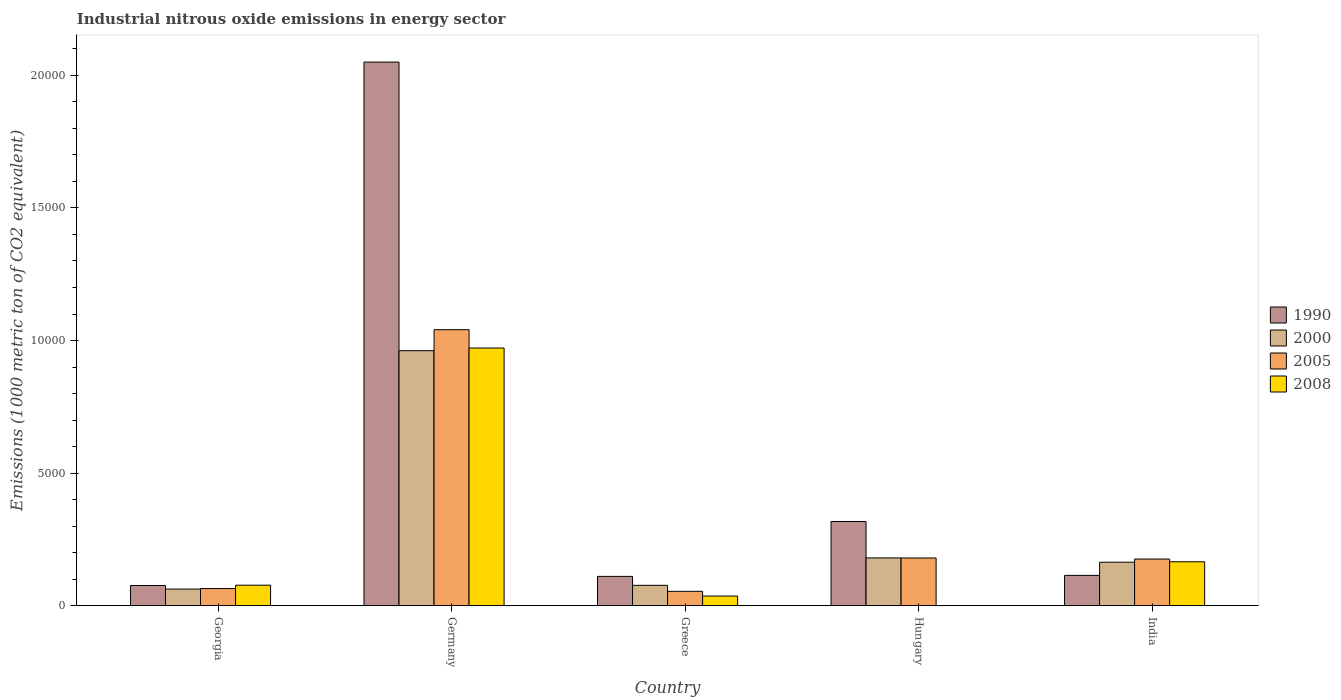Are the number of bars per tick equal to the number of legend labels?
Make the answer very short. Yes. What is the label of the 1st group of bars from the left?
Your answer should be very brief. Georgia. What is the amount of industrial nitrous oxide emitted in 1990 in Hungary?
Your response must be concise. 3178.6. Across all countries, what is the maximum amount of industrial nitrous oxide emitted in 2008?
Offer a very short reply. 9718.4. In which country was the amount of industrial nitrous oxide emitted in 2000 minimum?
Provide a succinct answer. Georgia. What is the total amount of industrial nitrous oxide emitted in 2005 in the graph?
Make the answer very short. 1.52e+04. What is the difference between the amount of industrial nitrous oxide emitted in 2000 in Greece and that in Hungary?
Keep it short and to the point. -1034.4. What is the difference between the amount of industrial nitrous oxide emitted in 2005 in Greece and the amount of industrial nitrous oxide emitted in 2000 in India?
Give a very brief answer. -1097.5. What is the average amount of industrial nitrous oxide emitted in 2000 per country?
Offer a very short reply. 2893.62. What is the difference between the amount of industrial nitrous oxide emitted of/in 2000 and amount of industrial nitrous oxide emitted of/in 2005 in Georgia?
Your answer should be very brief. -19.6. In how many countries, is the amount of industrial nitrous oxide emitted in 2000 greater than 9000 1000 metric ton?
Offer a very short reply. 1. What is the ratio of the amount of industrial nitrous oxide emitted in 2005 in Greece to that in India?
Provide a succinct answer. 0.31. Is the difference between the amount of industrial nitrous oxide emitted in 2000 in Georgia and Hungary greater than the difference between the amount of industrial nitrous oxide emitted in 2005 in Georgia and Hungary?
Make the answer very short. No. What is the difference between the highest and the second highest amount of industrial nitrous oxide emitted in 1990?
Ensure brevity in your answer.  -1.73e+04. What is the difference between the highest and the lowest amount of industrial nitrous oxide emitted in 1990?
Provide a succinct answer. 1.97e+04. Are all the bars in the graph horizontal?
Your answer should be compact. No. What is the difference between two consecutive major ticks on the Y-axis?
Your answer should be compact. 5000. Are the values on the major ticks of Y-axis written in scientific E-notation?
Give a very brief answer. No. Does the graph contain grids?
Offer a very short reply. No. How many legend labels are there?
Offer a terse response. 4. How are the legend labels stacked?
Offer a very short reply. Vertical. What is the title of the graph?
Ensure brevity in your answer.  Industrial nitrous oxide emissions in energy sector. Does "2015" appear as one of the legend labels in the graph?
Your answer should be very brief. No. What is the label or title of the X-axis?
Your answer should be compact. Country. What is the label or title of the Y-axis?
Your response must be concise. Emissions (1000 metric ton of CO2 equivalent). What is the Emissions (1000 metric ton of CO2 equivalent) in 1990 in Georgia?
Your answer should be compact. 765.3. What is the Emissions (1000 metric ton of CO2 equivalent) in 2000 in Georgia?
Offer a terse response. 630.5. What is the Emissions (1000 metric ton of CO2 equivalent) of 2005 in Georgia?
Offer a terse response. 650.1. What is the Emissions (1000 metric ton of CO2 equivalent) in 2008 in Georgia?
Give a very brief answer. 776.5. What is the Emissions (1000 metric ton of CO2 equivalent) in 1990 in Germany?
Offer a terse response. 2.05e+04. What is the Emissions (1000 metric ton of CO2 equivalent) of 2000 in Germany?
Give a very brief answer. 9617.9. What is the Emissions (1000 metric ton of CO2 equivalent) in 2005 in Germany?
Make the answer very short. 1.04e+04. What is the Emissions (1000 metric ton of CO2 equivalent) in 2008 in Germany?
Provide a short and direct response. 9718.4. What is the Emissions (1000 metric ton of CO2 equivalent) of 1990 in Greece?
Your response must be concise. 1109.1. What is the Emissions (1000 metric ton of CO2 equivalent) of 2000 in Greece?
Your response must be concise. 771. What is the Emissions (1000 metric ton of CO2 equivalent) in 2005 in Greece?
Provide a succinct answer. 545.8. What is the Emissions (1000 metric ton of CO2 equivalent) in 2008 in Greece?
Offer a terse response. 367.4. What is the Emissions (1000 metric ton of CO2 equivalent) of 1990 in Hungary?
Provide a succinct answer. 3178.6. What is the Emissions (1000 metric ton of CO2 equivalent) of 2000 in Hungary?
Offer a terse response. 1805.4. What is the Emissions (1000 metric ton of CO2 equivalent) in 2005 in Hungary?
Offer a terse response. 1802. What is the Emissions (1000 metric ton of CO2 equivalent) of 2008 in Hungary?
Make the answer very short. 6. What is the Emissions (1000 metric ton of CO2 equivalent) in 1990 in India?
Your answer should be compact. 1146.7. What is the Emissions (1000 metric ton of CO2 equivalent) of 2000 in India?
Offer a very short reply. 1643.3. What is the Emissions (1000 metric ton of CO2 equivalent) of 2005 in India?
Offer a very short reply. 1761.9. What is the Emissions (1000 metric ton of CO2 equivalent) of 2008 in India?
Offer a terse response. 1659.8. Across all countries, what is the maximum Emissions (1000 metric ton of CO2 equivalent) of 1990?
Provide a succinct answer. 2.05e+04. Across all countries, what is the maximum Emissions (1000 metric ton of CO2 equivalent) in 2000?
Make the answer very short. 9617.9. Across all countries, what is the maximum Emissions (1000 metric ton of CO2 equivalent) of 2005?
Ensure brevity in your answer.  1.04e+04. Across all countries, what is the maximum Emissions (1000 metric ton of CO2 equivalent) of 2008?
Provide a short and direct response. 9718.4. Across all countries, what is the minimum Emissions (1000 metric ton of CO2 equivalent) in 1990?
Provide a short and direct response. 765.3. Across all countries, what is the minimum Emissions (1000 metric ton of CO2 equivalent) in 2000?
Provide a succinct answer. 630.5. Across all countries, what is the minimum Emissions (1000 metric ton of CO2 equivalent) of 2005?
Provide a succinct answer. 545.8. What is the total Emissions (1000 metric ton of CO2 equivalent) of 1990 in the graph?
Provide a succinct answer. 2.67e+04. What is the total Emissions (1000 metric ton of CO2 equivalent) of 2000 in the graph?
Make the answer very short. 1.45e+04. What is the total Emissions (1000 metric ton of CO2 equivalent) of 2005 in the graph?
Offer a very short reply. 1.52e+04. What is the total Emissions (1000 metric ton of CO2 equivalent) in 2008 in the graph?
Provide a succinct answer. 1.25e+04. What is the difference between the Emissions (1000 metric ton of CO2 equivalent) of 1990 in Georgia and that in Germany?
Your response must be concise. -1.97e+04. What is the difference between the Emissions (1000 metric ton of CO2 equivalent) in 2000 in Georgia and that in Germany?
Provide a short and direct response. -8987.4. What is the difference between the Emissions (1000 metric ton of CO2 equivalent) in 2005 in Georgia and that in Germany?
Give a very brief answer. -9758.8. What is the difference between the Emissions (1000 metric ton of CO2 equivalent) of 2008 in Georgia and that in Germany?
Give a very brief answer. -8941.9. What is the difference between the Emissions (1000 metric ton of CO2 equivalent) of 1990 in Georgia and that in Greece?
Make the answer very short. -343.8. What is the difference between the Emissions (1000 metric ton of CO2 equivalent) in 2000 in Georgia and that in Greece?
Ensure brevity in your answer.  -140.5. What is the difference between the Emissions (1000 metric ton of CO2 equivalent) in 2005 in Georgia and that in Greece?
Provide a succinct answer. 104.3. What is the difference between the Emissions (1000 metric ton of CO2 equivalent) in 2008 in Georgia and that in Greece?
Your answer should be compact. 409.1. What is the difference between the Emissions (1000 metric ton of CO2 equivalent) of 1990 in Georgia and that in Hungary?
Give a very brief answer. -2413.3. What is the difference between the Emissions (1000 metric ton of CO2 equivalent) in 2000 in Georgia and that in Hungary?
Keep it short and to the point. -1174.9. What is the difference between the Emissions (1000 metric ton of CO2 equivalent) in 2005 in Georgia and that in Hungary?
Your answer should be compact. -1151.9. What is the difference between the Emissions (1000 metric ton of CO2 equivalent) of 2008 in Georgia and that in Hungary?
Provide a short and direct response. 770.5. What is the difference between the Emissions (1000 metric ton of CO2 equivalent) in 1990 in Georgia and that in India?
Offer a very short reply. -381.4. What is the difference between the Emissions (1000 metric ton of CO2 equivalent) of 2000 in Georgia and that in India?
Ensure brevity in your answer.  -1012.8. What is the difference between the Emissions (1000 metric ton of CO2 equivalent) in 2005 in Georgia and that in India?
Offer a terse response. -1111.8. What is the difference between the Emissions (1000 metric ton of CO2 equivalent) in 2008 in Georgia and that in India?
Your answer should be compact. -883.3. What is the difference between the Emissions (1000 metric ton of CO2 equivalent) in 1990 in Germany and that in Greece?
Provide a succinct answer. 1.94e+04. What is the difference between the Emissions (1000 metric ton of CO2 equivalent) in 2000 in Germany and that in Greece?
Offer a terse response. 8846.9. What is the difference between the Emissions (1000 metric ton of CO2 equivalent) of 2005 in Germany and that in Greece?
Provide a succinct answer. 9863.1. What is the difference between the Emissions (1000 metric ton of CO2 equivalent) in 2008 in Germany and that in Greece?
Keep it short and to the point. 9351. What is the difference between the Emissions (1000 metric ton of CO2 equivalent) of 1990 in Germany and that in Hungary?
Your answer should be very brief. 1.73e+04. What is the difference between the Emissions (1000 metric ton of CO2 equivalent) in 2000 in Germany and that in Hungary?
Offer a terse response. 7812.5. What is the difference between the Emissions (1000 metric ton of CO2 equivalent) of 2005 in Germany and that in Hungary?
Your answer should be very brief. 8606.9. What is the difference between the Emissions (1000 metric ton of CO2 equivalent) of 2008 in Germany and that in Hungary?
Provide a succinct answer. 9712.4. What is the difference between the Emissions (1000 metric ton of CO2 equivalent) in 1990 in Germany and that in India?
Offer a terse response. 1.94e+04. What is the difference between the Emissions (1000 metric ton of CO2 equivalent) in 2000 in Germany and that in India?
Give a very brief answer. 7974.6. What is the difference between the Emissions (1000 metric ton of CO2 equivalent) in 2005 in Germany and that in India?
Offer a terse response. 8647. What is the difference between the Emissions (1000 metric ton of CO2 equivalent) of 2008 in Germany and that in India?
Give a very brief answer. 8058.6. What is the difference between the Emissions (1000 metric ton of CO2 equivalent) of 1990 in Greece and that in Hungary?
Provide a succinct answer. -2069.5. What is the difference between the Emissions (1000 metric ton of CO2 equivalent) of 2000 in Greece and that in Hungary?
Ensure brevity in your answer.  -1034.4. What is the difference between the Emissions (1000 metric ton of CO2 equivalent) in 2005 in Greece and that in Hungary?
Provide a short and direct response. -1256.2. What is the difference between the Emissions (1000 metric ton of CO2 equivalent) in 2008 in Greece and that in Hungary?
Keep it short and to the point. 361.4. What is the difference between the Emissions (1000 metric ton of CO2 equivalent) in 1990 in Greece and that in India?
Provide a short and direct response. -37.6. What is the difference between the Emissions (1000 metric ton of CO2 equivalent) in 2000 in Greece and that in India?
Your response must be concise. -872.3. What is the difference between the Emissions (1000 metric ton of CO2 equivalent) in 2005 in Greece and that in India?
Your response must be concise. -1216.1. What is the difference between the Emissions (1000 metric ton of CO2 equivalent) of 2008 in Greece and that in India?
Ensure brevity in your answer.  -1292.4. What is the difference between the Emissions (1000 metric ton of CO2 equivalent) in 1990 in Hungary and that in India?
Keep it short and to the point. 2031.9. What is the difference between the Emissions (1000 metric ton of CO2 equivalent) in 2000 in Hungary and that in India?
Provide a short and direct response. 162.1. What is the difference between the Emissions (1000 metric ton of CO2 equivalent) in 2005 in Hungary and that in India?
Keep it short and to the point. 40.1. What is the difference between the Emissions (1000 metric ton of CO2 equivalent) in 2008 in Hungary and that in India?
Offer a terse response. -1653.8. What is the difference between the Emissions (1000 metric ton of CO2 equivalent) in 1990 in Georgia and the Emissions (1000 metric ton of CO2 equivalent) in 2000 in Germany?
Keep it short and to the point. -8852.6. What is the difference between the Emissions (1000 metric ton of CO2 equivalent) of 1990 in Georgia and the Emissions (1000 metric ton of CO2 equivalent) of 2005 in Germany?
Your answer should be compact. -9643.6. What is the difference between the Emissions (1000 metric ton of CO2 equivalent) of 1990 in Georgia and the Emissions (1000 metric ton of CO2 equivalent) of 2008 in Germany?
Ensure brevity in your answer.  -8953.1. What is the difference between the Emissions (1000 metric ton of CO2 equivalent) of 2000 in Georgia and the Emissions (1000 metric ton of CO2 equivalent) of 2005 in Germany?
Give a very brief answer. -9778.4. What is the difference between the Emissions (1000 metric ton of CO2 equivalent) of 2000 in Georgia and the Emissions (1000 metric ton of CO2 equivalent) of 2008 in Germany?
Keep it short and to the point. -9087.9. What is the difference between the Emissions (1000 metric ton of CO2 equivalent) of 2005 in Georgia and the Emissions (1000 metric ton of CO2 equivalent) of 2008 in Germany?
Offer a terse response. -9068.3. What is the difference between the Emissions (1000 metric ton of CO2 equivalent) of 1990 in Georgia and the Emissions (1000 metric ton of CO2 equivalent) of 2000 in Greece?
Your answer should be very brief. -5.7. What is the difference between the Emissions (1000 metric ton of CO2 equivalent) of 1990 in Georgia and the Emissions (1000 metric ton of CO2 equivalent) of 2005 in Greece?
Your response must be concise. 219.5. What is the difference between the Emissions (1000 metric ton of CO2 equivalent) in 1990 in Georgia and the Emissions (1000 metric ton of CO2 equivalent) in 2008 in Greece?
Offer a very short reply. 397.9. What is the difference between the Emissions (1000 metric ton of CO2 equivalent) in 2000 in Georgia and the Emissions (1000 metric ton of CO2 equivalent) in 2005 in Greece?
Your answer should be compact. 84.7. What is the difference between the Emissions (1000 metric ton of CO2 equivalent) of 2000 in Georgia and the Emissions (1000 metric ton of CO2 equivalent) of 2008 in Greece?
Offer a very short reply. 263.1. What is the difference between the Emissions (1000 metric ton of CO2 equivalent) of 2005 in Georgia and the Emissions (1000 metric ton of CO2 equivalent) of 2008 in Greece?
Your response must be concise. 282.7. What is the difference between the Emissions (1000 metric ton of CO2 equivalent) of 1990 in Georgia and the Emissions (1000 metric ton of CO2 equivalent) of 2000 in Hungary?
Provide a short and direct response. -1040.1. What is the difference between the Emissions (1000 metric ton of CO2 equivalent) in 1990 in Georgia and the Emissions (1000 metric ton of CO2 equivalent) in 2005 in Hungary?
Keep it short and to the point. -1036.7. What is the difference between the Emissions (1000 metric ton of CO2 equivalent) in 1990 in Georgia and the Emissions (1000 metric ton of CO2 equivalent) in 2008 in Hungary?
Provide a short and direct response. 759.3. What is the difference between the Emissions (1000 metric ton of CO2 equivalent) of 2000 in Georgia and the Emissions (1000 metric ton of CO2 equivalent) of 2005 in Hungary?
Your answer should be very brief. -1171.5. What is the difference between the Emissions (1000 metric ton of CO2 equivalent) in 2000 in Georgia and the Emissions (1000 metric ton of CO2 equivalent) in 2008 in Hungary?
Give a very brief answer. 624.5. What is the difference between the Emissions (1000 metric ton of CO2 equivalent) of 2005 in Georgia and the Emissions (1000 metric ton of CO2 equivalent) of 2008 in Hungary?
Your response must be concise. 644.1. What is the difference between the Emissions (1000 metric ton of CO2 equivalent) of 1990 in Georgia and the Emissions (1000 metric ton of CO2 equivalent) of 2000 in India?
Your response must be concise. -878. What is the difference between the Emissions (1000 metric ton of CO2 equivalent) in 1990 in Georgia and the Emissions (1000 metric ton of CO2 equivalent) in 2005 in India?
Provide a short and direct response. -996.6. What is the difference between the Emissions (1000 metric ton of CO2 equivalent) of 1990 in Georgia and the Emissions (1000 metric ton of CO2 equivalent) of 2008 in India?
Offer a very short reply. -894.5. What is the difference between the Emissions (1000 metric ton of CO2 equivalent) in 2000 in Georgia and the Emissions (1000 metric ton of CO2 equivalent) in 2005 in India?
Provide a short and direct response. -1131.4. What is the difference between the Emissions (1000 metric ton of CO2 equivalent) of 2000 in Georgia and the Emissions (1000 metric ton of CO2 equivalent) of 2008 in India?
Your answer should be compact. -1029.3. What is the difference between the Emissions (1000 metric ton of CO2 equivalent) of 2005 in Georgia and the Emissions (1000 metric ton of CO2 equivalent) of 2008 in India?
Your answer should be very brief. -1009.7. What is the difference between the Emissions (1000 metric ton of CO2 equivalent) of 1990 in Germany and the Emissions (1000 metric ton of CO2 equivalent) of 2000 in Greece?
Offer a terse response. 1.97e+04. What is the difference between the Emissions (1000 metric ton of CO2 equivalent) of 1990 in Germany and the Emissions (1000 metric ton of CO2 equivalent) of 2005 in Greece?
Your response must be concise. 2.00e+04. What is the difference between the Emissions (1000 metric ton of CO2 equivalent) of 1990 in Germany and the Emissions (1000 metric ton of CO2 equivalent) of 2008 in Greece?
Offer a very short reply. 2.01e+04. What is the difference between the Emissions (1000 metric ton of CO2 equivalent) of 2000 in Germany and the Emissions (1000 metric ton of CO2 equivalent) of 2005 in Greece?
Ensure brevity in your answer.  9072.1. What is the difference between the Emissions (1000 metric ton of CO2 equivalent) in 2000 in Germany and the Emissions (1000 metric ton of CO2 equivalent) in 2008 in Greece?
Your answer should be very brief. 9250.5. What is the difference between the Emissions (1000 metric ton of CO2 equivalent) in 2005 in Germany and the Emissions (1000 metric ton of CO2 equivalent) in 2008 in Greece?
Offer a very short reply. 1.00e+04. What is the difference between the Emissions (1000 metric ton of CO2 equivalent) in 1990 in Germany and the Emissions (1000 metric ton of CO2 equivalent) in 2000 in Hungary?
Ensure brevity in your answer.  1.87e+04. What is the difference between the Emissions (1000 metric ton of CO2 equivalent) in 1990 in Germany and the Emissions (1000 metric ton of CO2 equivalent) in 2005 in Hungary?
Make the answer very short. 1.87e+04. What is the difference between the Emissions (1000 metric ton of CO2 equivalent) in 1990 in Germany and the Emissions (1000 metric ton of CO2 equivalent) in 2008 in Hungary?
Make the answer very short. 2.05e+04. What is the difference between the Emissions (1000 metric ton of CO2 equivalent) in 2000 in Germany and the Emissions (1000 metric ton of CO2 equivalent) in 2005 in Hungary?
Provide a short and direct response. 7815.9. What is the difference between the Emissions (1000 metric ton of CO2 equivalent) in 2000 in Germany and the Emissions (1000 metric ton of CO2 equivalent) in 2008 in Hungary?
Give a very brief answer. 9611.9. What is the difference between the Emissions (1000 metric ton of CO2 equivalent) in 2005 in Germany and the Emissions (1000 metric ton of CO2 equivalent) in 2008 in Hungary?
Keep it short and to the point. 1.04e+04. What is the difference between the Emissions (1000 metric ton of CO2 equivalent) of 1990 in Germany and the Emissions (1000 metric ton of CO2 equivalent) of 2000 in India?
Your response must be concise. 1.89e+04. What is the difference between the Emissions (1000 metric ton of CO2 equivalent) of 1990 in Germany and the Emissions (1000 metric ton of CO2 equivalent) of 2005 in India?
Keep it short and to the point. 1.87e+04. What is the difference between the Emissions (1000 metric ton of CO2 equivalent) of 1990 in Germany and the Emissions (1000 metric ton of CO2 equivalent) of 2008 in India?
Offer a very short reply. 1.88e+04. What is the difference between the Emissions (1000 metric ton of CO2 equivalent) in 2000 in Germany and the Emissions (1000 metric ton of CO2 equivalent) in 2005 in India?
Provide a succinct answer. 7856. What is the difference between the Emissions (1000 metric ton of CO2 equivalent) in 2000 in Germany and the Emissions (1000 metric ton of CO2 equivalent) in 2008 in India?
Make the answer very short. 7958.1. What is the difference between the Emissions (1000 metric ton of CO2 equivalent) of 2005 in Germany and the Emissions (1000 metric ton of CO2 equivalent) of 2008 in India?
Provide a short and direct response. 8749.1. What is the difference between the Emissions (1000 metric ton of CO2 equivalent) of 1990 in Greece and the Emissions (1000 metric ton of CO2 equivalent) of 2000 in Hungary?
Your answer should be very brief. -696.3. What is the difference between the Emissions (1000 metric ton of CO2 equivalent) in 1990 in Greece and the Emissions (1000 metric ton of CO2 equivalent) in 2005 in Hungary?
Keep it short and to the point. -692.9. What is the difference between the Emissions (1000 metric ton of CO2 equivalent) in 1990 in Greece and the Emissions (1000 metric ton of CO2 equivalent) in 2008 in Hungary?
Make the answer very short. 1103.1. What is the difference between the Emissions (1000 metric ton of CO2 equivalent) of 2000 in Greece and the Emissions (1000 metric ton of CO2 equivalent) of 2005 in Hungary?
Give a very brief answer. -1031. What is the difference between the Emissions (1000 metric ton of CO2 equivalent) in 2000 in Greece and the Emissions (1000 metric ton of CO2 equivalent) in 2008 in Hungary?
Give a very brief answer. 765. What is the difference between the Emissions (1000 metric ton of CO2 equivalent) in 2005 in Greece and the Emissions (1000 metric ton of CO2 equivalent) in 2008 in Hungary?
Make the answer very short. 539.8. What is the difference between the Emissions (1000 metric ton of CO2 equivalent) in 1990 in Greece and the Emissions (1000 metric ton of CO2 equivalent) in 2000 in India?
Keep it short and to the point. -534.2. What is the difference between the Emissions (1000 metric ton of CO2 equivalent) in 1990 in Greece and the Emissions (1000 metric ton of CO2 equivalent) in 2005 in India?
Provide a succinct answer. -652.8. What is the difference between the Emissions (1000 metric ton of CO2 equivalent) in 1990 in Greece and the Emissions (1000 metric ton of CO2 equivalent) in 2008 in India?
Keep it short and to the point. -550.7. What is the difference between the Emissions (1000 metric ton of CO2 equivalent) of 2000 in Greece and the Emissions (1000 metric ton of CO2 equivalent) of 2005 in India?
Your response must be concise. -990.9. What is the difference between the Emissions (1000 metric ton of CO2 equivalent) of 2000 in Greece and the Emissions (1000 metric ton of CO2 equivalent) of 2008 in India?
Keep it short and to the point. -888.8. What is the difference between the Emissions (1000 metric ton of CO2 equivalent) of 2005 in Greece and the Emissions (1000 metric ton of CO2 equivalent) of 2008 in India?
Your response must be concise. -1114. What is the difference between the Emissions (1000 metric ton of CO2 equivalent) in 1990 in Hungary and the Emissions (1000 metric ton of CO2 equivalent) in 2000 in India?
Provide a short and direct response. 1535.3. What is the difference between the Emissions (1000 metric ton of CO2 equivalent) of 1990 in Hungary and the Emissions (1000 metric ton of CO2 equivalent) of 2005 in India?
Provide a succinct answer. 1416.7. What is the difference between the Emissions (1000 metric ton of CO2 equivalent) in 1990 in Hungary and the Emissions (1000 metric ton of CO2 equivalent) in 2008 in India?
Ensure brevity in your answer.  1518.8. What is the difference between the Emissions (1000 metric ton of CO2 equivalent) of 2000 in Hungary and the Emissions (1000 metric ton of CO2 equivalent) of 2005 in India?
Your answer should be compact. 43.5. What is the difference between the Emissions (1000 metric ton of CO2 equivalent) in 2000 in Hungary and the Emissions (1000 metric ton of CO2 equivalent) in 2008 in India?
Give a very brief answer. 145.6. What is the difference between the Emissions (1000 metric ton of CO2 equivalent) of 2005 in Hungary and the Emissions (1000 metric ton of CO2 equivalent) of 2008 in India?
Provide a short and direct response. 142.2. What is the average Emissions (1000 metric ton of CO2 equivalent) in 1990 per country?
Your answer should be very brief. 5339.86. What is the average Emissions (1000 metric ton of CO2 equivalent) of 2000 per country?
Your response must be concise. 2893.62. What is the average Emissions (1000 metric ton of CO2 equivalent) of 2005 per country?
Give a very brief answer. 3033.74. What is the average Emissions (1000 metric ton of CO2 equivalent) in 2008 per country?
Make the answer very short. 2505.62. What is the difference between the Emissions (1000 metric ton of CO2 equivalent) of 1990 and Emissions (1000 metric ton of CO2 equivalent) of 2000 in Georgia?
Make the answer very short. 134.8. What is the difference between the Emissions (1000 metric ton of CO2 equivalent) in 1990 and Emissions (1000 metric ton of CO2 equivalent) in 2005 in Georgia?
Ensure brevity in your answer.  115.2. What is the difference between the Emissions (1000 metric ton of CO2 equivalent) in 2000 and Emissions (1000 metric ton of CO2 equivalent) in 2005 in Georgia?
Make the answer very short. -19.6. What is the difference between the Emissions (1000 metric ton of CO2 equivalent) of 2000 and Emissions (1000 metric ton of CO2 equivalent) of 2008 in Georgia?
Provide a succinct answer. -146. What is the difference between the Emissions (1000 metric ton of CO2 equivalent) of 2005 and Emissions (1000 metric ton of CO2 equivalent) of 2008 in Georgia?
Offer a very short reply. -126.4. What is the difference between the Emissions (1000 metric ton of CO2 equivalent) of 1990 and Emissions (1000 metric ton of CO2 equivalent) of 2000 in Germany?
Make the answer very short. 1.09e+04. What is the difference between the Emissions (1000 metric ton of CO2 equivalent) in 1990 and Emissions (1000 metric ton of CO2 equivalent) in 2005 in Germany?
Provide a succinct answer. 1.01e+04. What is the difference between the Emissions (1000 metric ton of CO2 equivalent) of 1990 and Emissions (1000 metric ton of CO2 equivalent) of 2008 in Germany?
Your answer should be compact. 1.08e+04. What is the difference between the Emissions (1000 metric ton of CO2 equivalent) of 2000 and Emissions (1000 metric ton of CO2 equivalent) of 2005 in Germany?
Offer a very short reply. -791. What is the difference between the Emissions (1000 metric ton of CO2 equivalent) of 2000 and Emissions (1000 metric ton of CO2 equivalent) of 2008 in Germany?
Make the answer very short. -100.5. What is the difference between the Emissions (1000 metric ton of CO2 equivalent) in 2005 and Emissions (1000 metric ton of CO2 equivalent) in 2008 in Germany?
Make the answer very short. 690.5. What is the difference between the Emissions (1000 metric ton of CO2 equivalent) in 1990 and Emissions (1000 metric ton of CO2 equivalent) in 2000 in Greece?
Ensure brevity in your answer.  338.1. What is the difference between the Emissions (1000 metric ton of CO2 equivalent) of 1990 and Emissions (1000 metric ton of CO2 equivalent) of 2005 in Greece?
Make the answer very short. 563.3. What is the difference between the Emissions (1000 metric ton of CO2 equivalent) of 1990 and Emissions (1000 metric ton of CO2 equivalent) of 2008 in Greece?
Make the answer very short. 741.7. What is the difference between the Emissions (1000 metric ton of CO2 equivalent) in 2000 and Emissions (1000 metric ton of CO2 equivalent) in 2005 in Greece?
Provide a succinct answer. 225.2. What is the difference between the Emissions (1000 metric ton of CO2 equivalent) in 2000 and Emissions (1000 metric ton of CO2 equivalent) in 2008 in Greece?
Keep it short and to the point. 403.6. What is the difference between the Emissions (1000 metric ton of CO2 equivalent) in 2005 and Emissions (1000 metric ton of CO2 equivalent) in 2008 in Greece?
Offer a terse response. 178.4. What is the difference between the Emissions (1000 metric ton of CO2 equivalent) in 1990 and Emissions (1000 metric ton of CO2 equivalent) in 2000 in Hungary?
Offer a very short reply. 1373.2. What is the difference between the Emissions (1000 metric ton of CO2 equivalent) of 1990 and Emissions (1000 metric ton of CO2 equivalent) of 2005 in Hungary?
Your answer should be compact. 1376.6. What is the difference between the Emissions (1000 metric ton of CO2 equivalent) in 1990 and Emissions (1000 metric ton of CO2 equivalent) in 2008 in Hungary?
Provide a short and direct response. 3172.6. What is the difference between the Emissions (1000 metric ton of CO2 equivalent) in 2000 and Emissions (1000 metric ton of CO2 equivalent) in 2005 in Hungary?
Your answer should be compact. 3.4. What is the difference between the Emissions (1000 metric ton of CO2 equivalent) of 2000 and Emissions (1000 metric ton of CO2 equivalent) of 2008 in Hungary?
Your response must be concise. 1799.4. What is the difference between the Emissions (1000 metric ton of CO2 equivalent) of 2005 and Emissions (1000 metric ton of CO2 equivalent) of 2008 in Hungary?
Give a very brief answer. 1796. What is the difference between the Emissions (1000 metric ton of CO2 equivalent) in 1990 and Emissions (1000 metric ton of CO2 equivalent) in 2000 in India?
Keep it short and to the point. -496.6. What is the difference between the Emissions (1000 metric ton of CO2 equivalent) of 1990 and Emissions (1000 metric ton of CO2 equivalent) of 2005 in India?
Provide a short and direct response. -615.2. What is the difference between the Emissions (1000 metric ton of CO2 equivalent) in 1990 and Emissions (1000 metric ton of CO2 equivalent) in 2008 in India?
Ensure brevity in your answer.  -513.1. What is the difference between the Emissions (1000 metric ton of CO2 equivalent) of 2000 and Emissions (1000 metric ton of CO2 equivalent) of 2005 in India?
Keep it short and to the point. -118.6. What is the difference between the Emissions (1000 metric ton of CO2 equivalent) in 2000 and Emissions (1000 metric ton of CO2 equivalent) in 2008 in India?
Keep it short and to the point. -16.5. What is the difference between the Emissions (1000 metric ton of CO2 equivalent) of 2005 and Emissions (1000 metric ton of CO2 equivalent) of 2008 in India?
Keep it short and to the point. 102.1. What is the ratio of the Emissions (1000 metric ton of CO2 equivalent) of 1990 in Georgia to that in Germany?
Ensure brevity in your answer.  0.04. What is the ratio of the Emissions (1000 metric ton of CO2 equivalent) in 2000 in Georgia to that in Germany?
Offer a terse response. 0.07. What is the ratio of the Emissions (1000 metric ton of CO2 equivalent) in 2005 in Georgia to that in Germany?
Keep it short and to the point. 0.06. What is the ratio of the Emissions (1000 metric ton of CO2 equivalent) of 2008 in Georgia to that in Germany?
Your response must be concise. 0.08. What is the ratio of the Emissions (1000 metric ton of CO2 equivalent) of 1990 in Georgia to that in Greece?
Offer a very short reply. 0.69. What is the ratio of the Emissions (1000 metric ton of CO2 equivalent) in 2000 in Georgia to that in Greece?
Offer a terse response. 0.82. What is the ratio of the Emissions (1000 metric ton of CO2 equivalent) of 2005 in Georgia to that in Greece?
Your answer should be very brief. 1.19. What is the ratio of the Emissions (1000 metric ton of CO2 equivalent) in 2008 in Georgia to that in Greece?
Make the answer very short. 2.11. What is the ratio of the Emissions (1000 metric ton of CO2 equivalent) of 1990 in Georgia to that in Hungary?
Ensure brevity in your answer.  0.24. What is the ratio of the Emissions (1000 metric ton of CO2 equivalent) in 2000 in Georgia to that in Hungary?
Offer a terse response. 0.35. What is the ratio of the Emissions (1000 metric ton of CO2 equivalent) in 2005 in Georgia to that in Hungary?
Offer a very short reply. 0.36. What is the ratio of the Emissions (1000 metric ton of CO2 equivalent) of 2008 in Georgia to that in Hungary?
Keep it short and to the point. 129.42. What is the ratio of the Emissions (1000 metric ton of CO2 equivalent) in 1990 in Georgia to that in India?
Keep it short and to the point. 0.67. What is the ratio of the Emissions (1000 metric ton of CO2 equivalent) of 2000 in Georgia to that in India?
Give a very brief answer. 0.38. What is the ratio of the Emissions (1000 metric ton of CO2 equivalent) in 2005 in Georgia to that in India?
Give a very brief answer. 0.37. What is the ratio of the Emissions (1000 metric ton of CO2 equivalent) of 2008 in Georgia to that in India?
Ensure brevity in your answer.  0.47. What is the ratio of the Emissions (1000 metric ton of CO2 equivalent) in 1990 in Germany to that in Greece?
Make the answer very short. 18.48. What is the ratio of the Emissions (1000 metric ton of CO2 equivalent) in 2000 in Germany to that in Greece?
Provide a succinct answer. 12.47. What is the ratio of the Emissions (1000 metric ton of CO2 equivalent) in 2005 in Germany to that in Greece?
Provide a succinct answer. 19.07. What is the ratio of the Emissions (1000 metric ton of CO2 equivalent) in 2008 in Germany to that in Greece?
Give a very brief answer. 26.45. What is the ratio of the Emissions (1000 metric ton of CO2 equivalent) in 1990 in Germany to that in Hungary?
Make the answer very short. 6.45. What is the ratio of the Emissions (1000 metric ton of CO2 equivalent) in 2000 in Germany to that in Hungary?
Your answer should be very brief. 5.33. What is the ratio of the Emissions (1000 metric ton of CO2 equivalent) in 2005 in Germany to that in Hungary?
Your response must be concise. 5.78. What is the ratio of the Emissions (1000 metric ton of CO2 equivalent) of 2008 in Germany to that in Hungary?
Make the answer very short. 1619.73. What is the ratio of the Emissions (1000 metric ton of CO2 equivalent) in 1990 in Germany to that in India?
Your answer should be very brief. 17.88. What is the ratio of the Emissions (1000 metric ton of CO2 equivalent) in 2000 in Germany to that in India?
Your answer should be very brief. 5.85. What is the ratio of the Emissions (1000 metric ton of CO2 equivalent) of 2005 in Germany to that in India?
Provide a succinct answer. 5.91. What is the ratio of the Emissions (1000 metric ton of CO2 equivalent) of 2008 in Germany to that in India?
Your answer should be very brief. 5.86. What is the ratio of the Emissions (1000 metric ton of CO2 equivalent) in 1990 in Greece to that in Hungary?
Provide a short and direct response. 0.35. What is the ratio of the Emissions (1000 metric ton of CO2 equivalent) of 2000 in Greece to that in Hungary?
Your answer should be very brief. 0.43. What is the ratio of the Emissions (1000 metric ton of CO2 equivalent) of 2005 in Greece to that in Hungary?
Provide a short and direct response. 0.3. What is the ratio of the Emissions (1000 metric ton of CO2 equivalent) in 2008 in Greece to that in Hungary?
Your answer should be compact. 61.23. What is the ratio of the Emissions (1000 metric ton of CO2 equivalent) of 1990 in Greece to that in India?
Your response must be concise. 0.97. What is the ratio of the Emissions (1000 metric ton of CO2 equivalent) of 2000 in Greece to that in India?
Make the answer very short. 0.47. What is the ratio of the Emissions (1000 metric ton of CO2 equivalent) of 2005 in Greece to that in India?
Provide a short and direct response. 0.31. What is the ratio of the Emissions (1000 metric ton of CO2 equivalent) in 2008 in Greece to that in India?
Offer a very short reply. 0.22. What is the ratio of the Emissions (1000 metric ton of CO2 equivalent) of 1990 in Hungary to that in India?
Your response must be concise. 2.77. What is the ratio of the Emissions (1000 metric ton of CO2 equivalent) of 2000 in Hungary to that in India?
Keep it short and to the point. 1.1. What is the ratio of the Emissions (1000 metric ton of CO2 equivalent) in 2005 in Hungary to that in India?
Give a very brief answer. 1.02. What is the ratio of the Emissions (1000 metric ton of CO2 equivalent) in 2008 in Hungary to that in India?
Ensure brevity in your answer.  0. What is the difference between the highest and the second highest Emissions (1000 metric ton of CO2 equivalent) in 1990?
Your answer should be compact. 1.73e+04. What is the difference between the highest and the second highest Emissions (1000 metric ton of CO2 equivalent) of 2000?
Your answer should be very brief. 7812.5. What is the difference between the highest and the second highest Emissions (1000 metric ton of CO2 equivalent) of 2005?
Make the answer very short. 8606.9. What is the difference between the highest and the second highest Emissions (1000 metric ton of CO2 equivalent) in 2008?
Keep it short and to the point. 8058.6. What is the difference between the highest and the lowest Emissions (1000 metric ton of CO2 equivalent) of 1990?
Ensure brevity in your answer.  1.97e+04. What is the difference between the highest and the lowest Emissions (1000 metric ton of CO2 equivalent) in 2000?
Keep it short and to the point. 8987.4. What is the difference between the highest and the lowest Emissions (1000 metric ton of CO2 equivalent) of 2005?
Make the answer very short. 9863.1. What is the difference between the highest and the lowest Emissions (1000 metric ton of CO2 equivalent) in 2008?
Give a very brief answer. 9712.4. 